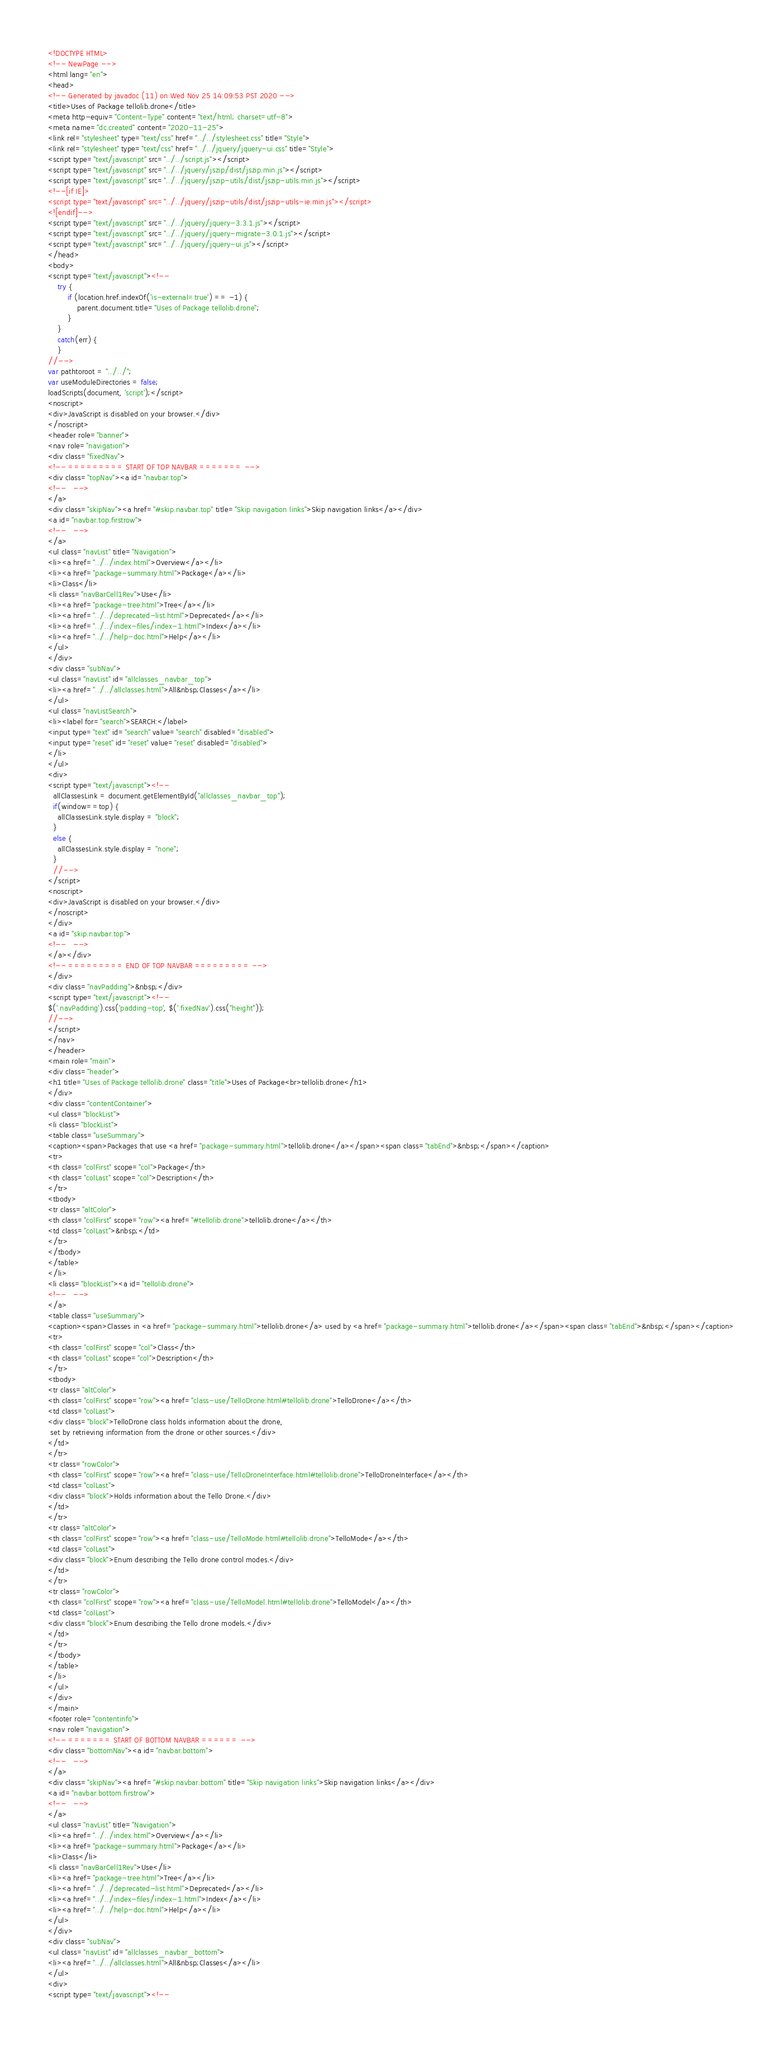<code> <loc_0><loc_0><loc_500><loc_500><_HTML_><!DOCTYPE HTML>
<!-- NewPage -->
<html lang="en">
<head>
<!-- Generated by javadoc (11) on Wed Nov 25 14:09:53 PST 2020 -->
<title>Uses of Package tellolib.drone</title>
<meta http-equiv="Content-Type" content="text/html; charset=utf-8">
<meta name="dc.created" content="2020-11-25">
<link rel="stylesheet" type="text/css" href="../../stylesheet.css" title="Style">
<link rel="stylesheet" type="text/css" href="../../jquery/jquery-ui.css" title="Style">
<script type="text/javascript" src="../../script.js"></script>
<script type="text/javascript" src="../../jquery/jszip/dist/jszip.min.js"></script>
<script type="text/javascript" src="../../jquery/jszip-utils/dist/jszip-utils.min.js"></script>
<!--[if IE]>
<script type="text/javascript" src="../../jquery/jszip-utils/dist/jszip-utils-ie.min.js"></script>
<![endif]-->
<script type="text/javascript" src="../../jquery/jquery-3.3.1.js"></script>
<script type="text/javascript" src="../../jquery/jquery-migrate-3.0.1.js"></script>
<script type="text/javascript" src="../../jquery/jquery-ui.js"></script>
</head>
<body>
<script type="text/javascript"><!--
    try {
        if (location.href.indexOf('is-external=true') == -1) {
            parent.document.title="Uses of Package tellolib.drone";
        }
    }
    catch(err) {
    }
//-->
var pathtoroot = "../../";
var useModuleDirectories = false;
loadScripts(document, 'script');</script>
<noscript>
<div>JavaScript is disabled on your browser.</div>
</noscript>
<header role="banner">
<nav role="navigation">
<div class="fixedNav">
<!-- ========= START OF TOP NAVBAR ======= -->
<div class="topNav"><a id="navbar.top">
<!--   -->
</a>
<div class="skipNav"><a href="#skip.navbar.top" title="Skip navigation links">Skip navigation links</a></div>
<a id="navbar.top.firstrow">
<!--   -->
</a>
<ul class="navList" title="Navigation">
<li><a href="../../index.html">Overview</a></li>
<li><a href="package-summary.html">Package</a></li>
<li>Class</li>
<li class="navBarCell1Rev">Use</li>
<li><a href="package-tree.html">Tree</a></li>
<li><a href="../../deprecated-list.html">Deprecated</a></li>
<li><a href="../../index-files/index-1.html">Index</a></li>
<li><a href="../../help-doc.html">Help</a></li>
</ul>
</div>
<div class="subNav">
<ul class="navList" id="allclasses_navbar_top">
<li><a href="../../allclasses.html">All&nbsp;Classes</a></li>
</ul>
<ul class="navListSearch">
<li><label for="search">SEARCH:</label>
<input type="text" id="search" value="search" disabled="disabled">
<input type="reset" id="reset" value="reset" disabled="disabled">
</li>
</ul>
<div>
<script type="text/javascript"><!--
  allClassesLink = document.getElementById("allclasses_navbar_top");
  if(window==top) {
    allClassesLink.style.display = "block";
  }
  else {
    allClassesLink.style.display = "none";
  }
  //-->
</script>
<noscript>
<div>JavaScript is disabled on your browser.</div>
</noscript>
</div>
<a id="skip.navbar.top">
<!--   -->
</a></div>
<!-- ========= END OF TOP NAVBAR ========= -->
</div>
<div class="navPadding">&nbsp;</div>
<script type="text/javascript"><!--
$('.navPadding').css('padding-top', $('.fixedNav').css("height"));
//-->
</script>
</nav>
</header>
<main role="main">
<div class="header">
<h1 title="Uses of Package tellolib.drone" class="title">Uses of Package<br>tellolib.drone</h1>
</div>
<div class="contentContainer">
<ul class="blockList">
<li class="blockList">
<table class="useSummary">
<caption><span>Packages that use <a href="package-summary.html">tellolib.drone</a></span><span class="tabEnd">&nbsp;</span></caption>
<tr>
<th class="colFirst" scope="col">Package</th>
<th class="colLast" scope="col">Description</th>
</tr>
<tbody>
<tr class="altColor">
<th class="colFirst" scope="row"><a href="#tellolib.drone">tellolib.drone</a></th>
<td class="colLast">&nbsp;</td>
</tr>
</tbody>
</table>
</li>
<li class="blockList"><a id="tellolib.drone">
<!--   -->
</a>
<table class="useSummary">
<caption><span>Classes in <a href="package-summary.html">tellolib.drone</a> used by <a href="package-summary.html">tellolib.drone</a></span><span class="tabEnd">&nbsp;</span></caption>
<tr>
<th class="colFirst" scope="col">Class</th>
<th class="colLast" scope="col">Description</th>
</tr>
<tbody>
<tr class="altColor">
<th class="colFirst" scope="row"><a href="class-use/TelloDrone.html#tellolib.drone">TelloDrone</a></th>
<td class="colLast">
<div class="block">TelloDrone class holds information about the drone,
 set by retrieving information from the drone or other sources.</div>
</td>
</tr>
<tr class="rowColor">
<th class="colFirst" scope="row"><a href="class-use/TelloDroneInterface.html#tellolib.drone">TelloDroneInterface</a></th>
<td class="colLast">
<div class="block">Holds information about the Tello Drone.</div>
</td>
</tr>
<tr class="altColor">
<th class="colFirst" scope="row"><a href="class-use/TelloMode.html#tellolib.drone">TelloMode</a></th>
<td class="colLast">
<div class="block">Enum describing the Tello drone control modes.</div>
</td>
</tr>
<tr class="rowColor">
<th class="colFirst" scope="row"><a href="class-use/TelloModel.html#tellolib.drone">TelloModel</a></th>
<td class="colLast">
<div class="block">Enum describing the Tello drone models.</div>
</td>
</tr>
</tbody>
</table>
</li>
</ul>
</div>
</main>
<footer role="contentinfo">
<nav role="navigation">
<!-- ======= START OF BOTTOM NAVBAR ====== -->
<div class="bottomNav"><a id="navbar.bottom">
<!--   -->
</a>
<div class="skipNav"><a href="#skip.navbar.bottom" title="Skip navigation links">Skip navigation links</a></div>
<a id="navbar.bottom.firstrow">
<!--   -->
</a>
<ul class="navList" title="Navigation">
<li><a href="../../index.html">Overview</a></li>
<li><a href="package-summary.html">Package</a></li>
<li>Class</li>
<li class="navBarCell1Rev">Use</li>
<li><a href="package-tree.html">Tree</a></li>
<li><a href="../../deprecated-list.html">Deprecated</a></li>
<li><a href="../../index-files/index-1.html">Index</a></li>
<li><a href="../../help-doc.html">Help</a></li>
</ul>
</div>
<div class="subNav">
<ul class="navList" id="allclasses_navbar_bottom">
<li><a href="../../allclasses.html">All&nbsp;Classes</a></li>
</ul>
<div>
<script type="text/javascript"><!--</code> 